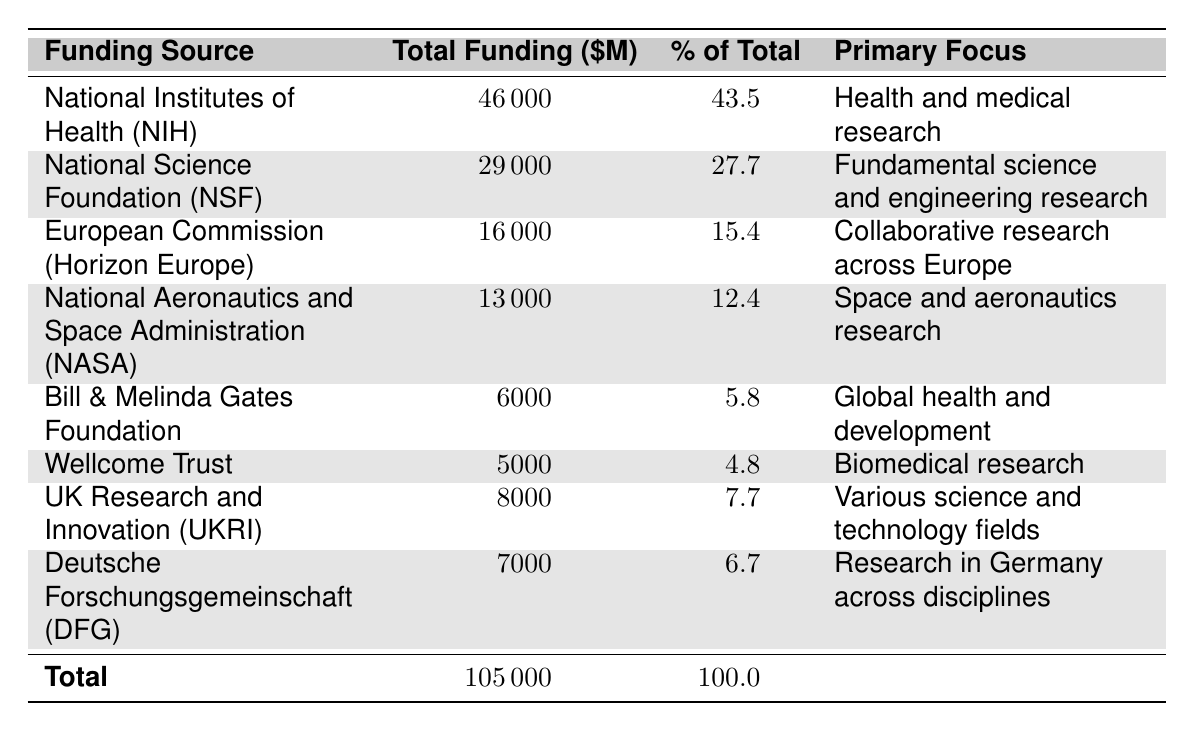What is the total funding from the National Institutes of Health (NIH)? The table shows that the total funding from NIH is listed as 46000 million dollars.
Answer: 46000 million dollars What percentage of the total funding does the National Science Foundation (NSF) represent? According to the table, NSF accounts for 27.7% of the total funding.
Answer: 27.7% How much funding is provided by the European Commission (Horizon Europe)? The table indicates that the European Commission provides 16000 million dollars in funding.
Answer: 16000 million dollars What is the total funding amount from all sources combined? The table lists the total funding amount as 105000 million dollars.
Answer: 105000 million dollars Which funding source has the highest total funding? From the table, the National Institutes of Health (NIH) has the highest total funding at 46000 million dollars.
Answer: National Institutes of Health (NIH) If you add the total funding from the Wellcome Trust and Bill & Melinda Gates Foundation, what would that be? The total funding from the Wellcome Trust is 5000 million dollars, and from the Gates Foundation is 6000 million dollars. Adding these gives 5000 + 6000 = 11000 million dollars.
Answer: 11000 million dollars Is the funding from NASA greater than that of the Gates Foundation? The table shows that NASA has 13000 million dollars while the Gates Foundation has 6000 million dollars, thus, 13000 is greater than 6000.
Answer: Yes What percentage of total funding is represented by both the Bill & Melinda Gates Foundation and Wellcome Trust combined? The Gates Foundation represents 5.8% and the Wellcome Trust represents 4.8%. Therefore, the combined percentage is 5.8 + 4.8 = 10.6%.
Answer: 10.6% Which two sources have a primary focus in health-related areas? The table indicates that NIH focuses on health and medical research, and the Gates Foundation focuses on global health and development.
Answer: NIH and Bill & Melinda Gates Foundation What is the average funding amount of the top three funding sources? The top three funding sources are NIH (46000 million), NSF (29000 million), and the European Commission (16000 million). The total for these three is 46000 + 29000 + 16000 = 91000 million dollars, and the average is 91000 / 3 = 30333.33 million dollars.
Answer: 30333.33 million dollars 